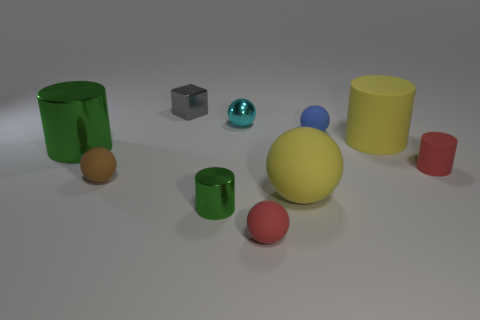What number of things are either big gray rubber blocks or cyan spheres?
Offer a terse response. 1. Does the brown rubber ball have the same size as the shiny thing in front of the large green object?
Offer a very short reply. Yes. There is a green shiny object that is to the right of the small gray thing that is on the right side of the ball that is to the left of the gray object; what is its size?
Make the answer very short. Small. Are there any cubes?
Your answer should be very brief. Yes. What is the material of the big cylinder that is the same color as the small shiny cylinder?
Offer a terse response. Metal. How many tiny metallic cubes are the same color as the small metal ball?
Ensure brevity in your answer.  0. What number of things are either large things in front of the blue matte ball or large objects left of the large rubber cylinder?
Make the answer very short. 3. What number of big spheres are in front of the tiny shiny thing on the left side of the tiny green object?
Your response must be concise. 1. The large ball that is the same material as the yellow cylinder is what color?
Ensure brevity in your answer.  Yellow. Are there any green objects that have the same size as the yellow rubber cylinder?
Give a very brief answer. Yes. 